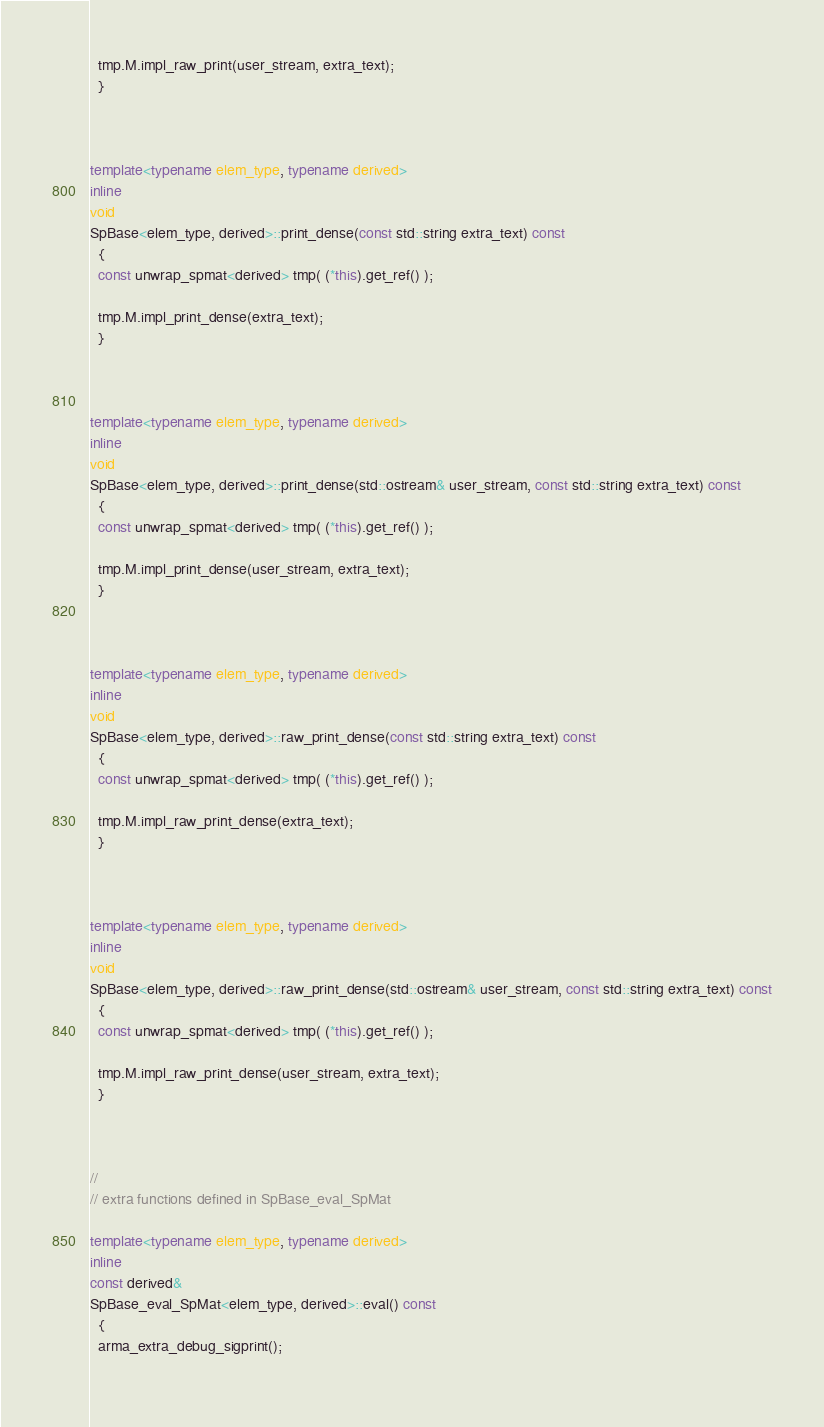Convert code to text. <code><loc_0><loc_0><loc_500><loc_500><_C++_>  tmp.M.impl_raw_print(user_stream, extra_text);
  }



template<typename elem_type, typename derived>
inline
void
SpBase<elem_type, derived>::print_dense(const std::string extra_text) const
  {
  const unwrap_spmat<derived> tmp( (*this).get_ref() );

  tmp.M.impl_print_dense(extra_text);
  }



template<typename elem_type, typename derived>
inline
void
SpBase<elem_type, derived>::print_dense(std::ostream& user_stream, const std::string extra_text) const
  {
  const unwrap_spmat<derived> tmp( (*this).get_ref() );

  tmp.M.impl_print_dense(user_stream, extra_text);
  }



template<typename elem_type, typename derived>
inline
void
SpBase<elem_type, derived>::raw_print_dense(const std::string extra_text) const
  {
  const unwrap_spmat<derived> tmp( (*this).get_ref() );

  tmp.M.impl_raw_print_dense(extra_text);
  }



template<typename elem_type, typename derived>
inline
void
SpBase<elem_type, derived>::raw_print_dense(std::ostream& user_stream, const std::string extra_text) const
  {
  const unwrap_spmat<derived> tmp( (*this).get_ref() );

  tmp.M.impl_raw_print_dense(user_stream, extra_text);
  }



//
// extra functions defined in SpBase_eval_SpMat

template<typename elem_type, typename derived>
inline
const derived&
SpBase_eval_SpMat<elem_type, derived>::eval() const
  {
  arma_extra_debug_sigprint();
  </code> 